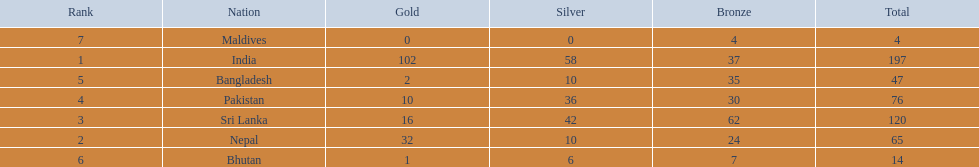What were the total amount won of medals by nations in the 1999 south asian games? 197, 65, 120, 76, 47, 14, 4. Which amount was the lowest? 4. Which nation had this amount? Maldives. 